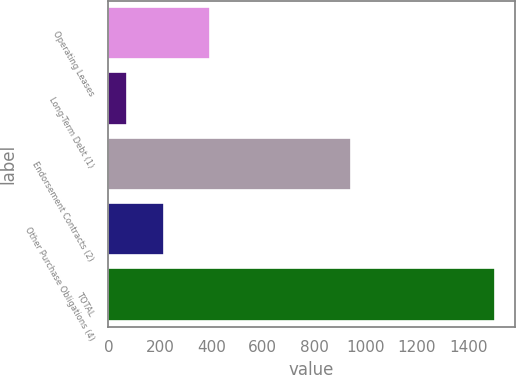Convert chart to OTSL. <chart><loc_0><loc_0><loc_500><loc_500><bar_chart><fcel>Operating Leases<fcel>Long-Term Debt (1)<fcel>Endorsement Contracts (2)<fcel>Other Purchase Obligations (4)<fcel>TOTAL<nl><fcel>395<fcel>74<fcel>945<fcel>217.2<fcel>1506<nl></chart> 